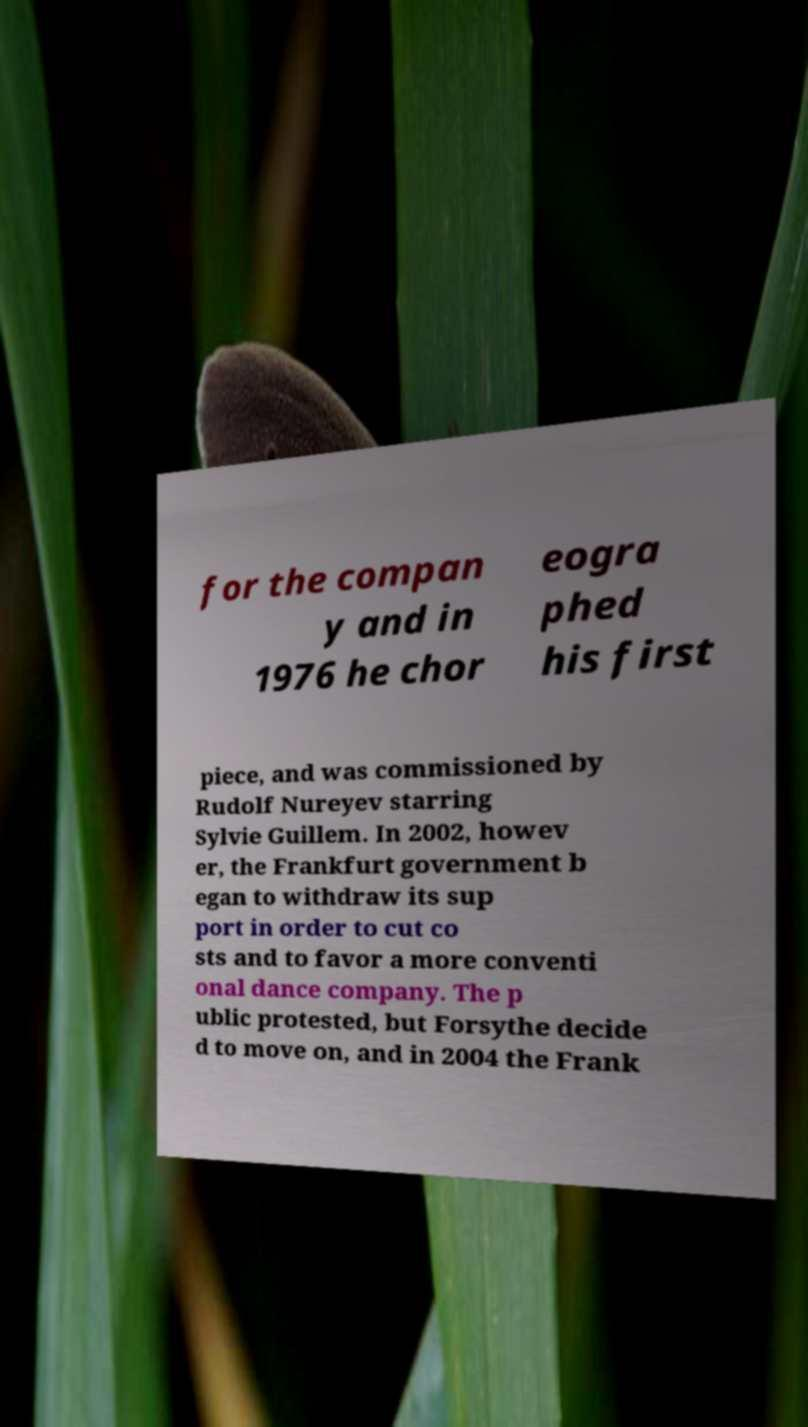Please identify and transcribe the text found in this image. for the compan y and in 1976 he chor eogra phed his first piece, and was commissioned by Rudolf Nureyev starring Sylvie Guillem. In 2002, howev er, the Frankfurt government b egan to withdraw its sup port in order to cut co sts and to favor a more conventi onal dance company. The p ublic protested, but Forsythe decide d to move on, and in 2004 the Frank 